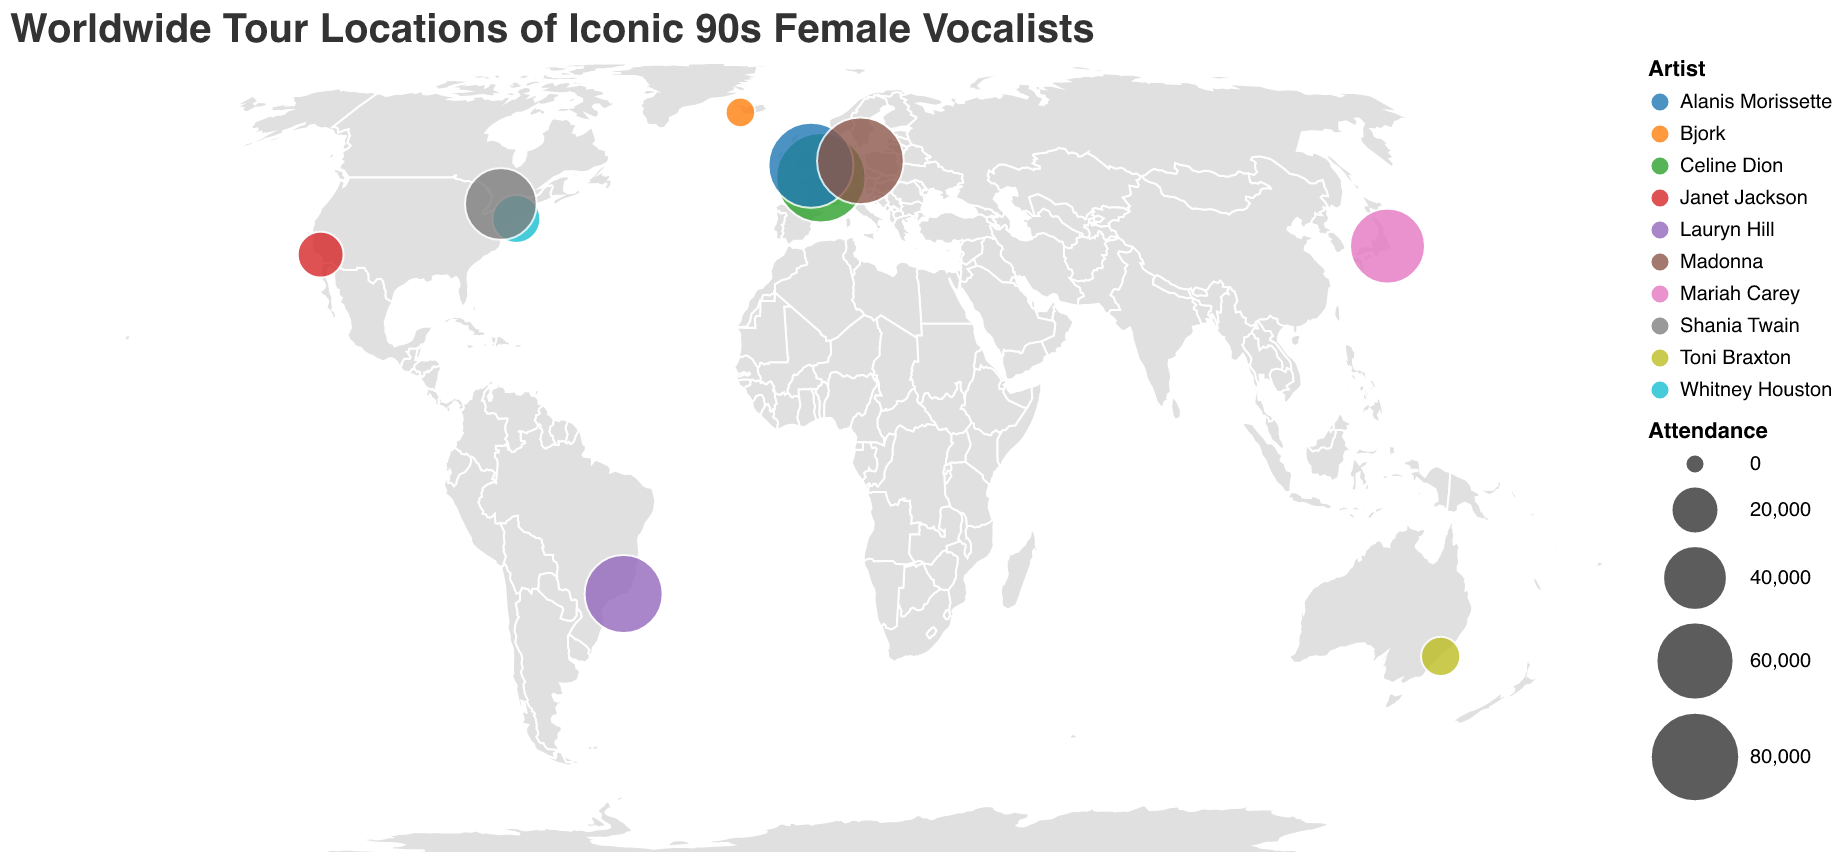Which artist performed at Tokyo Dome? The tooltip information for the Tokyo location indicates that Mariah Carey performed at Tokyo Dome.
Answer: Mariah Carey What is the title of the figure? The title is displayed at the top of the figure in a large font size.
Answer: Worldwide Tour Locations of Iconic 90s Female Vocalists Which city had the highest attendance? By comparing the circle sizes representing attendance across different cities, Paris has the largest circle, indicating the highest attendance.
Answer: Paris What's the difference in attendance between the performances in Paris and New York? Paris had an attendance of 80,000, and New York had an attendance of 20,000. The difference between these two numbers is 80,000 - 20,000 = 60,000.
Answer: 60,000 Among Tokyo, Reykjavik, and Sydney, which city had the lowest attendance? By comparing the circle sizes for Tokyo, Reykjavik, and Sydney, Reykjavik has the smallest circle size, indicating the lowest attendance of 5,000.
Answer: Reykjavik How many artists performed in the USA? From the data, we can see that Whitney Houston and Janet Jackson performed in New York and Los Angeles, both in the USA. Count these occurrences.
Answer: 2 What is the average attendance for the venues in Europe? Add up the attendances for Paris (80,000), London (72,000), Berlin (75,000), then divide by the number of venues: (80,000 + 72,000 + 75,000) / 3 = 227,000 / 3 = 75,666.67.
Answer: 75,666.67 Which artist had the largest venue attendance according to the plot? Comparing the largest circle sizes indicated in the plot, Celine Dion's venue in Paris has the highest attendance of 80,000.
Answer: Celine Dion What's the longitude of the venue in Brazil? The tooltip information for Rio de Janeiro in Brazil shows the longitude as -43.2289.
Answer: -43.2289 Which artist performed at the smallest venue? By checking the attendances in the tooltip information, Bjork performed at the smallest venue in Reykjavik, with 5,000 attendees.
Answer: Bjork 